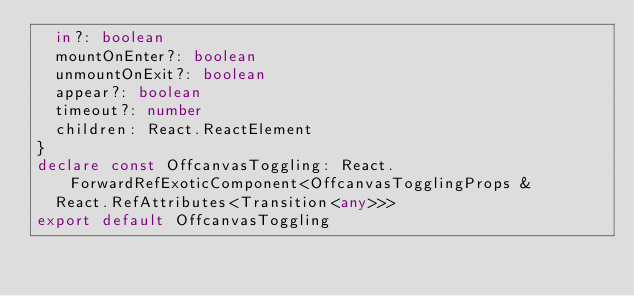<code> <loc_0><loc_0><loc_500><loc_500><_TypeScript_>  in?: boolean
  mountOnEnter?: boolean
  unmountOnExit?: boolean
  appear?: boolean
  timeout?: number
  children: React.ReactElement
}
declare const OffcanvasToggling: React.ForwardRefExoticComponent<OffcanvasTogglingProps &
  React.RefAttributes<Transition<any>>>
export default OffcanvasToggling
</code> 